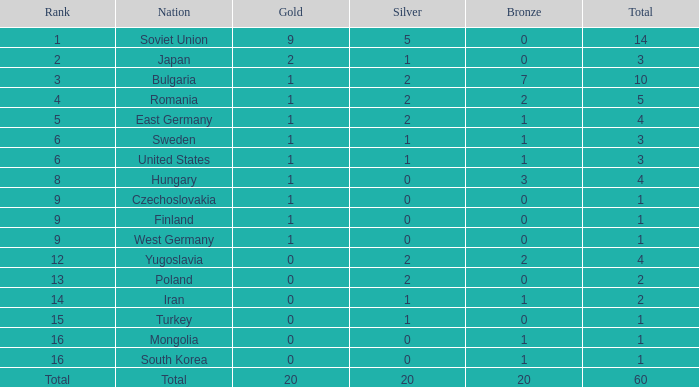What is the sum of bronzes having silvers over 5 and golds under 20? None. 